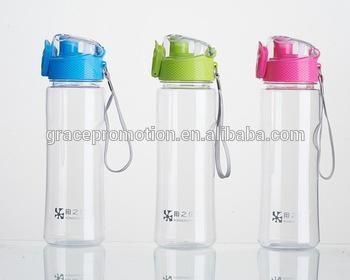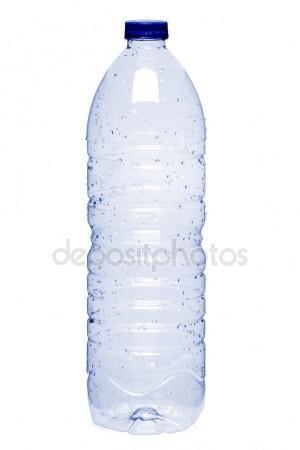The first image is the image on the left, the second image is the image on the right. Considering the images on both sides, is "In one image, a single drinking water bottle has a blue cap and no label." valid? Answer yes or no. Yes. 